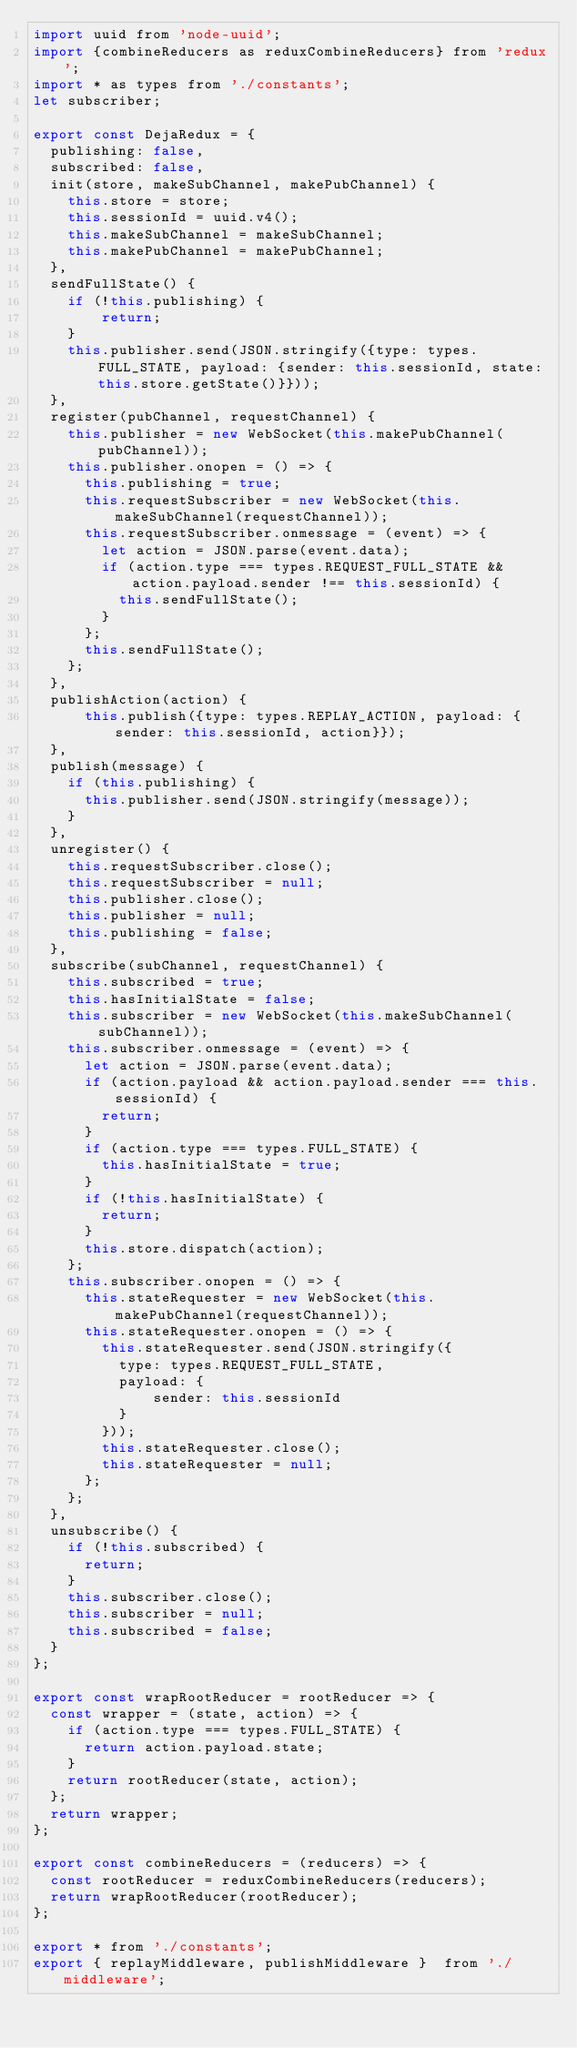Convert code to text. <code><loc_0><loc_0><loc_500><loc_500><_JavaScript_>import uuid from 'node-uuid';
import {combineReducers as reduxCombineReducers} from 'redux';
import * as types from './constants';
let subscriber;

export const DejaRedux = {
  publishing: false,
  subscribed: false,
  init(store, makeSubChannel, makePubChannel) {
    this.store = store;
    this.sessionId = uuid.v4();
    this.makeSubChannel = makeSubChannel;
    this.makePubChannel = makePubChannel;
  },
  sendFullState() {
    if (!this.publishing) {
        return;
    }
    this.publisher.send(JSON.stringify({type: types.FULL_STATE, payload: {sender: this.sessionId, state: this.store.getState()}}));
  },
  register(pubChannel, requestChannel) {
    this.publisher = new WebSocket(this.makePubChannel(pubChannel));
    this.publisher.onopen = () => {
      this.publishing = true;
      this.requestSubscriber = new WebSocket(this.makeSubChannel(requestChannel));
      this.requestSubscriber.onmessage = (event) => {
        let action = JSON.parse(event.data);
        if (action.type === types.REQUEST_FULL_STATE && action.payload.sender !== this.sessionId) {
          this.sendFullState();
        }
      };
      this.sendFullState();
    };
  },
  publishAction(action) {
      this.publish({type: types.REPLAY_ACTION, payload: {sender: this.sessionId, action}});
  },
  publish(message) {
    if (this.publishing) {
      this.publisher.send(JSON.stringify(message));
    }
  },
  unregister() {
    this.requestSubscriber.close();
    this.requestSubscriber = null;
    this.publisher.close();
    this.publisher = null;
    this.publishing = false;
  },
  subscribe(subChannel, requestChannel) {
    this.subscribed = true;
    this.hasInitialState = false;
    this.subscriber = new WebSocket(this.makeSubChannel(subChannel));
    this.subscriber.onmessage = (event) => {
      let action = JSON.parse(event.data);
      if (action.payload && action.payload.sender === this.sessionId) {
        return;
      }
      if (action.type === types.FULL_STATE) {
        this.hasInitialState = true;
      }
      if (!this.hasInitialState) {
        return;
      }
      this.store.dispatch(action);
    };
    this.subscriber.onopen = () => {
      this.stateRequester = new WebSocket(this.makePubChannel(requestChannel));
      this.stateRequester.onopen = () => {
        this.stateRequester.send(JSON.stringify({
          type: types.REQUEST_FULL_STATE,
          payload: {
              sender: this.sessionId
          }
        }));
        this.stateRequester.close();
        this.stateRequester = null;
      };
    };
  },
  unsubscribe() {
    if (!this.subscribed) {
      return;
    }
    this.subscriber.close();
    this.subscriber = null;
    this.subscribed = false;
  }
};

export const wrapRootReducer = rootReducer => {
  const wrapper = (state, action) => {
    if (action.type === types.FULL_STATE) {
      return action.payload.state;
    }
    return rootReducer(state, action);
  };
  return wrapper;
};

export const combineReducers = (reducers) => {
  const rootReducer = reduxCombineReducers(reducers);
  return wrapRootReducer(rootReducer);
};

export * from './constants';
export { replayMiddleware, publishMiddleware }  from './middleware';
</code> 